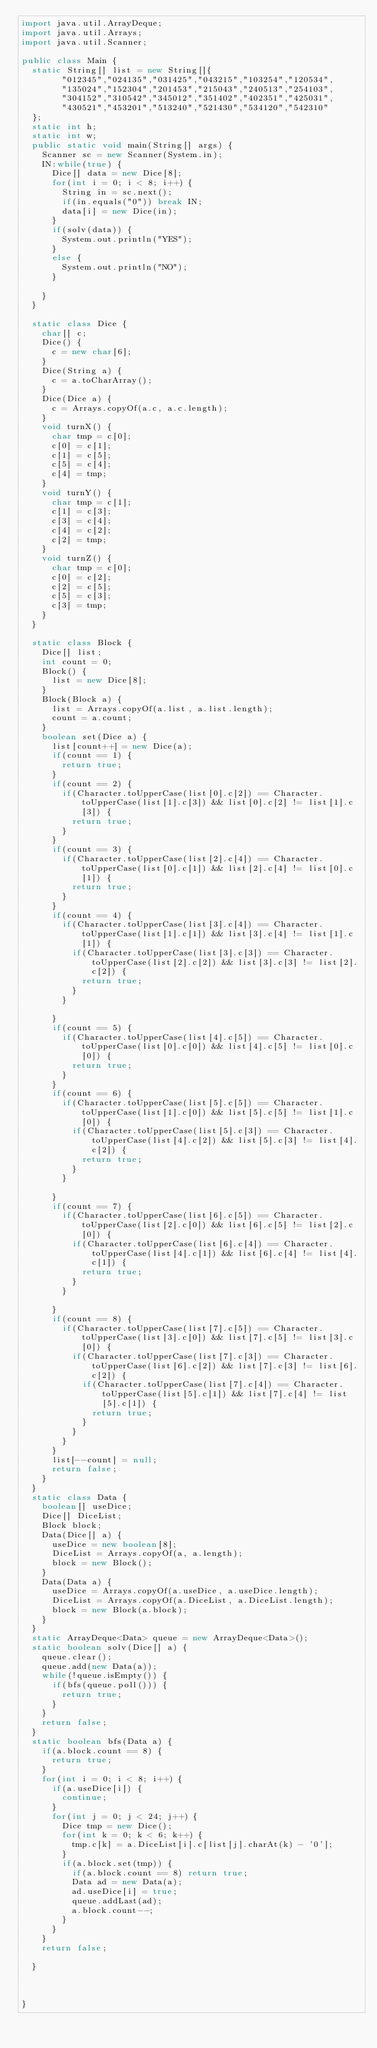<code> <loc_0><loc_0><loc_500><loc_500><_Java_>import java.util.ArrayDeque;
import java.util.Arrays;
import java.util.Scanner;

public class Main {
	static String[] list = new String[]{
		    "012345","024135","031425","043215","103254","120534",
		    "135024","152304","201453","215043","240513","254103",
		    "304152","310542","345012","351402","402351","425031",
		    "430521","453201","513240","521430","534120","542310"
	};
	static int h;
	static int w;
	public static void main(String[] args) {
		Scanner sc = new Scanner(System.in);
		IN:while(true) {
			Dice[] data = new Dice[8];
			for(int i = 0; i < 8; i++) {
				String in = sc.next();
				if(in.equals("0")) break IN;
				data[i] = new Dice(in);
			}
			if(solv(data)) {
				System.out.println("YES");
			}
			else {
				System.out.println("NO");
			}

		}
	}
	
	static class Dice {
		char[] c;
		Dice() {
			c = new char[6];
		}
		Dice(String a) {
			c = a.toCharArray();
		}
		Dice(Dice a) {
			c = Arrays.copyOf(a.c, a.c.length);
		}
		void turnX() {
			char tmp = c[0];
			c[0] = c[1];
			c[1] = c[5];
			c[5] = c[4];
			c[4] = tmp;
		}
		void turnY() {
			char tmp = c[1];
			c[1] = c[3];
			c[3] = c[4];
			c[4] = c[2];
			c[2] = tmp;
		}
		void turnZ() {
			char tmp = c[0];
			c[0] = c[2];
			c[2] = c[5];
			c[5] = c[3];
			c[3] = tmp;
		}
	}
	
	static class Block {
		Dice[] list;
		int count = 0;
		Block() {
			list = new Dice[8];
		}
		Block(Block a) {
			list = Arrays.copyOf(a.list, a.list.length);
			count = a.count;
		}
		boolean set(Dice a) {
			list[count++] = new Dice(a);
			if(count == 1) {
				return true;
			}
			if(count == 2) {
				if(Character.toUpperCase(list[0].c[2]) == Character.toUpperCase(list[1].c[3]) && list[0].c[2] != list[1].c[3]) {
					return true;
				}
			}
			if(count == 3) {
				if(Character.toUpperCase(list[2].c[4]) == Character.toUpperCase(list[0].c[1]) && list[2].c[4] != list[0].c[1]) {
					return true;
				}
			}
			if(count == 4) {
				if(Character.toUpperCase(list[3].c[4]) == Character.toUpperCase(list[1].c[1]) && list[3].c[4] != list[1].c[1]) {
					if(Character.toUpperCase(list[3].c[3]) == Character.toUpperCase(list[2].c[2]) && list[3].c[3] != list[2].c[2]) {
						return true;
					}
				}
				
			}
			if(count == 5) {
				if(Character.toUpperCase(list[4].c[5]) == Character.toUpperCase(list[0].c[0]) && list[4].c[5] != list[0].c[0]) {
					return true;
				}
			}
			if(count == 6) {
				if(Character.toUpperCase(list[5].c[5]) == Character.toUpperCase(list[1].c[0]) && list[5].c[5] != list[1].c[0]) {
					if(Character.toUpperCase(list[5].c[3]) == Character.toUpperCase(list[4].c[2]) && list[5].c[3] != list[4].c[2]) {
						return true;
					}
				}
				
			}
			if(count == 7) {
				if(Character.toUpperCase(list[6].c[5]) == Character.toUpperCase(list[2].c[0]) && list[6].c[5] != list[2].c[0]) {
					if(Character.toUpperCase(list[6].c[4]) == Character.toUpperCase(list[4].c[1]) && list[6].c[4] != list[4].c[1]) {
						return true;
					}
				}
				
			}
			if(count == 8) {
				if(Character.toUpperCase(list[7].c[5]) == Character.toUpperCase(list[3].c[0]) && list[7].c[5] != list[3].c[0]) {
					if(Character.toUpperCase(list[7].c[3]) == Character.toUpperCase(list[6].c[2]) && list[7].c[3] != list[6].c[2]) {
						if(Character.toUpperCase(list[7].c[4]) == Character.toUpperCase(list[5].c[1]) && list[7].c[4] != list[5].c[1]) {
							return true;
						}
					}
				}
			}
			list[--count] = null;
			return false;
		}
	}
	static class Data {
		boolean[] useDice;
		Dice[] DiceList;
		Block block;
		Data(Dice[] a) {
			useDice = new boolean[8];
			DiceList = Arrays.copyOf(a, a.length);
			block = new Block();
		}
		Data(Data a) {
			useDice = Arrays.copyOf(a.useDice, a.useDice.length);
			DiceList = Arrays.copyOf(a.DiceList, a.DiceList.length);
			block = new Block(a.block);
		}
	}
	static ArrayDeque<Data> queue = new ArrayDeque<Data>(); 
	static boolean solv(Dice[] a) {
		queue.clear();
		queue.add(new Data(a));
		while(!queue.isEmpty()) {
			if(bfs(queue.poll())) {
				return true;
			}
		}
		return false;
	}
	static boolean bfs(Data a) {
		if(a.block.count == 8) {
			return true;
		}
		for(int i = 0; i < 8; i++) {
			if(a.useDice[i]) {
				continue;
			}
			for(int j = 0; j < 24; j++) {
				Dice tmp = new Dice();
				for(int k = 0; k < 6; k++) {
					tmp.c[k] = a.DiceList[i].c[list[j].charAt(k) - '0']; 
				}
				if(a.block.set(tmp)) {
					if(a.block.count == 8) return true;
					Data ad = new Data(a);
					ad.useDice[i] = true;
					queue.addLast(ad);
					a.block.count--;
				}
			}
		}
		return false;
		
	}

	

}</code> 